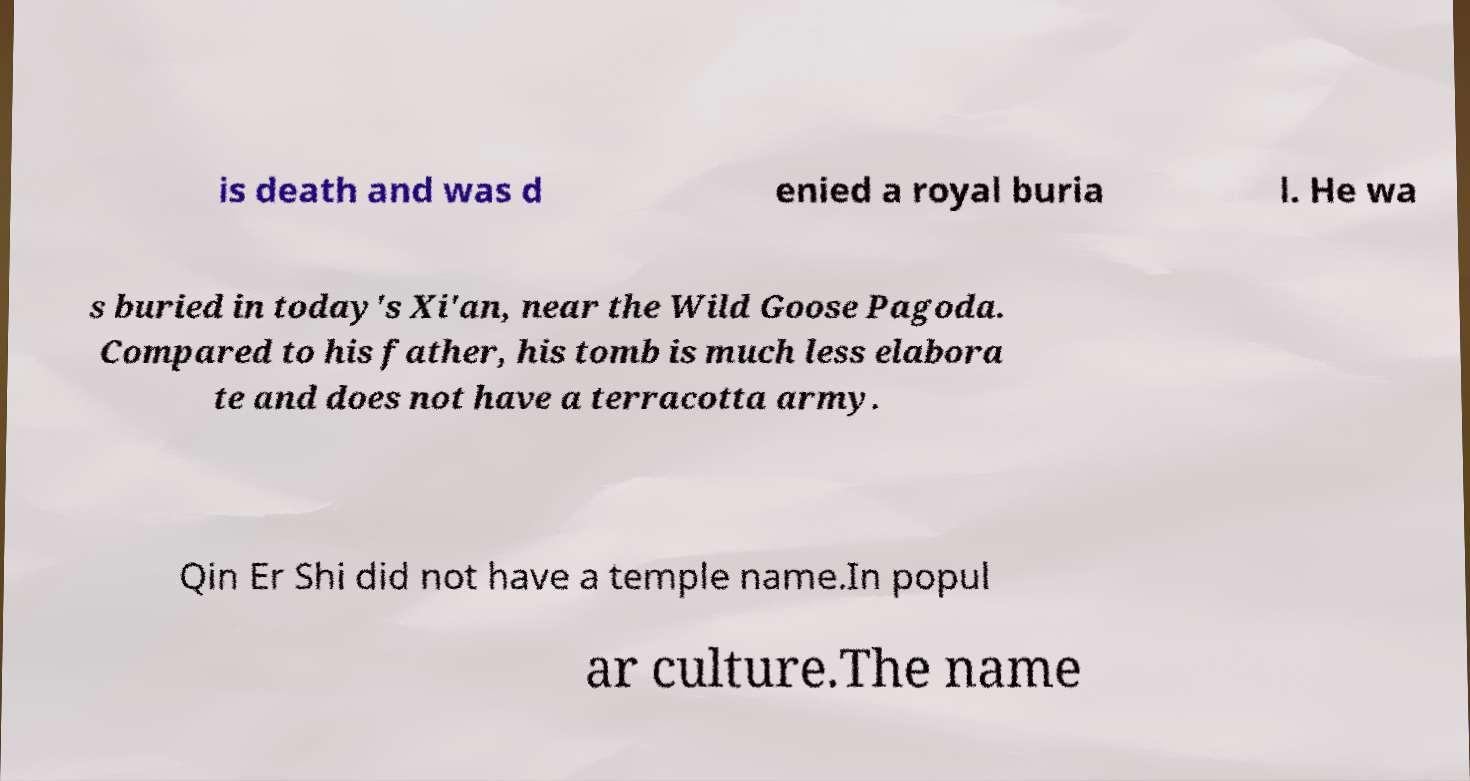Can you read and provide the text displayed in the image?This photo seems to have some interesting text. Can you extract and type it out for me? is death and was d enied a royal buria l. He wa s buried in today's Xi'an, near the Wild Goose Pagoda. Compared to his father, his tomb is much less elabora te and does not have a terracotta army. Qin Er Shi did not have a temple name.In popul ar culture.The name 